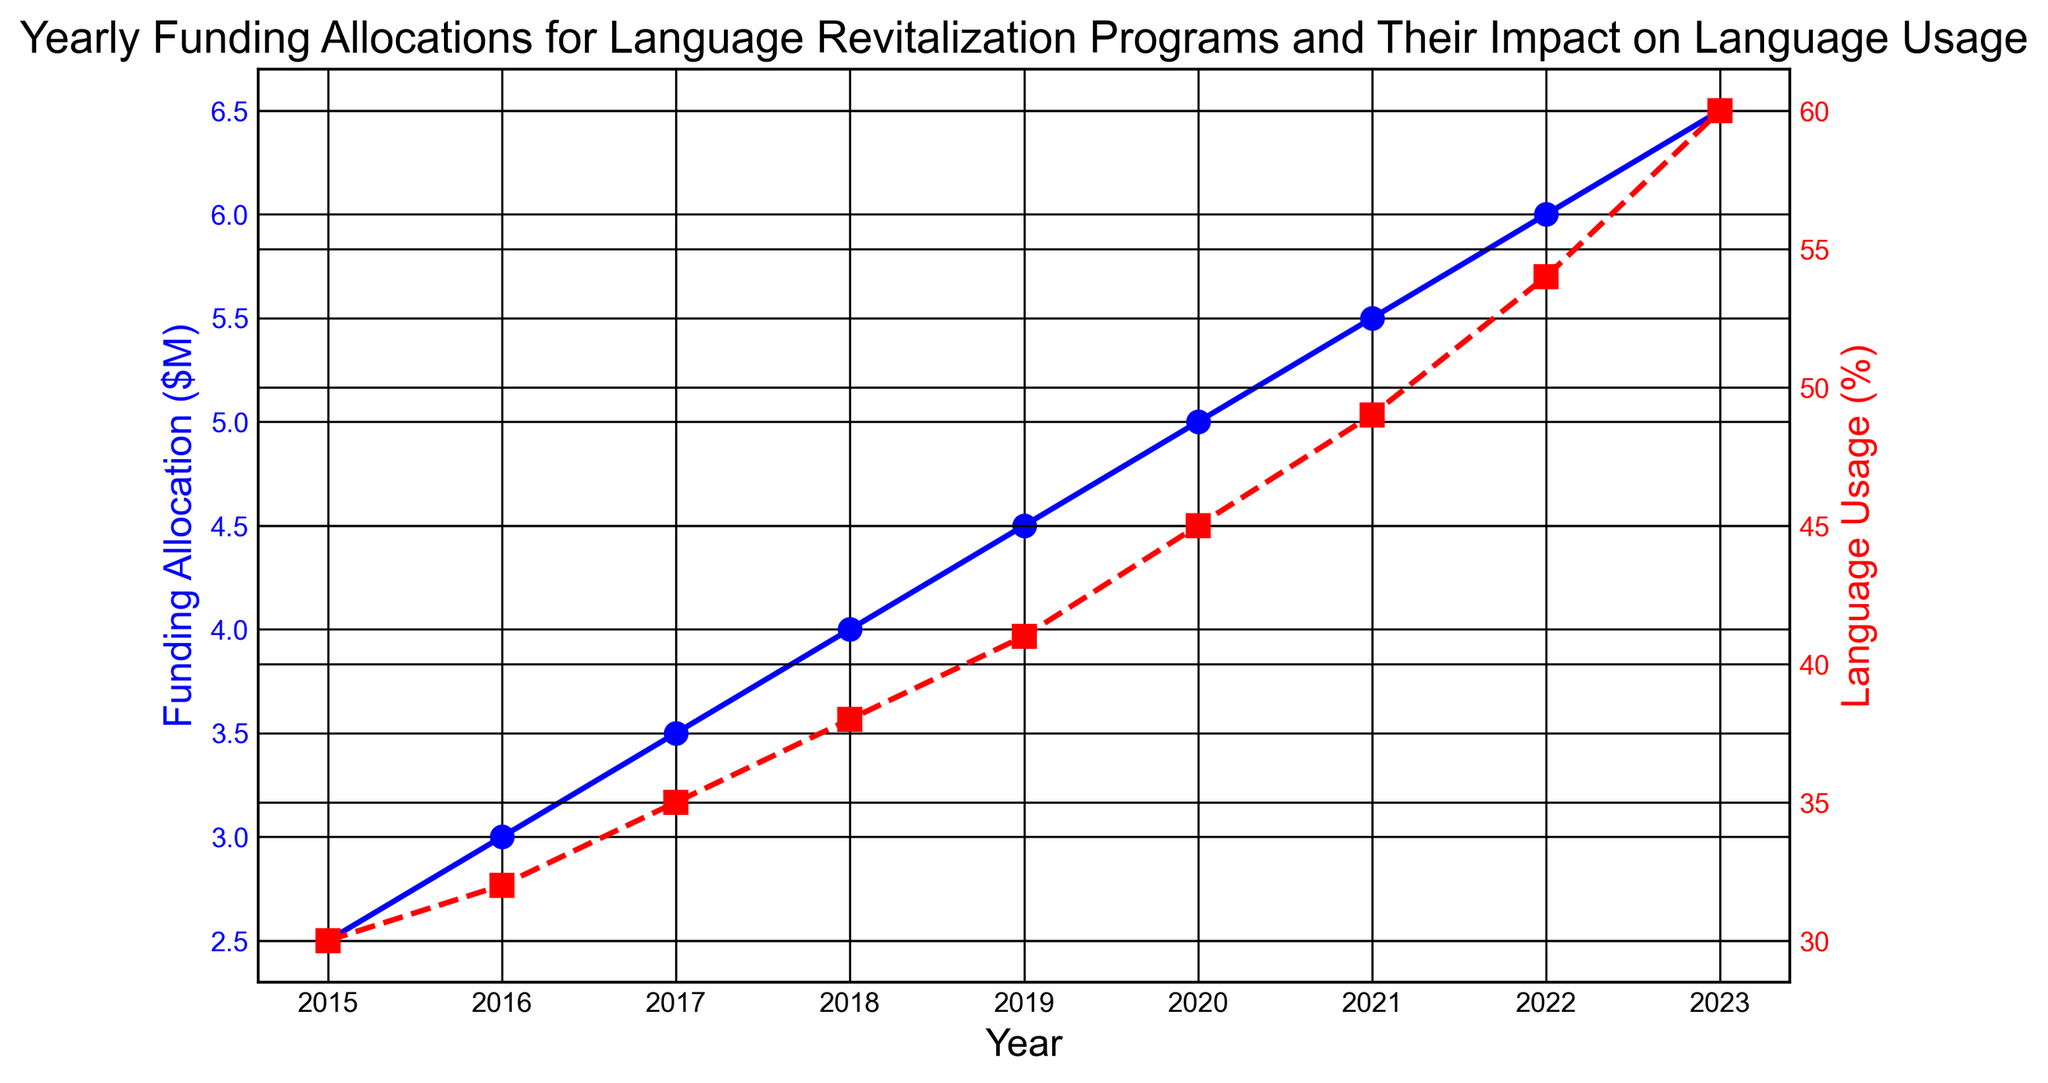What's the highest Language Usage (%) recorded on the chart? The highest value on the red line that represents Language Usage (%) is 60% in the year 2023.
Answer: 60% How many million dollars was allocated for language revitalization programs in 2020? Look at the blue line marking Funding Allocation ($M). For the year 2020, the funding was 5.0 million dollars.
Answer: 5.0 In which year did the Funding Allocation ($M) and Language Usage (%) see the largest absolute year-over-year increase respectively? For Funding Allocation ($M), the largest increase is from 2022 to 2023 (6.0M to 6.5M, increase of 0.5M). For Language Usage (%), the largest increase is also from 2022 to 2023 (54% to 60%, increase of 6%).
Answer: 2022-2023 What is the average annual Funding Allocation ($M) from 2015 to 2023? Sum the Funding Allocation ($M) from 2015 to 2023: 2.5 + 3.0 + 3.5 + 4.0 + 4.5 + 5.0 + 5.5 + 6.0 + 6.5 = 40.5. There are 9 years, so the average is 40.5 / 9 ≈ 4.5.
Answer: 4.5 By how much did Language Usage (%) increase from 2015 to 2023? Subtract the Language Usage (%) in 2015 from that in 2023: 60% (in 2023) - 30% (in 2015) = 30%.
Answer: 30% Which year had an equal value of 6 for Language Usage (%) and Funding Allocation ($M)? Look for the year where both values intersect at 6 if applicable. In 2022, Language Usage is 54%, and Funding Allocation is 6.0 million dollars.
Answer: 2022 In which year did the Funding Allocation ($M) surpass 5.0 million dollars for the first time? Look for when the blue line first goes above 5.0 million dollars. This happens in 2021 with a funding allocation of 5.5 million dollars.
Answer: 2021 Compare the trend in Language Usage (%) and Funding Allocation ($M) from 2015 to 2023. How do the trends relate to each other? Both the Funding Allocation and Language Usage show a steady increase over the years. As Funding Allocation ($M) increased, Language Usage (%) also increased consistently.
Answer: Both trends increase consistently What's the total Funding Allocation ($M) over the entire duration covered in the chart? Add all yearly values of Funding Allocation ($M) from 2015 to 2023: 2.5 + 3.0 + 3.5 + 4.0 + 4.5 + 5.0 + 5.5 + 6.0 + 6.5 = 40.5 million dollars.
Answer: 40.5 million dollars 